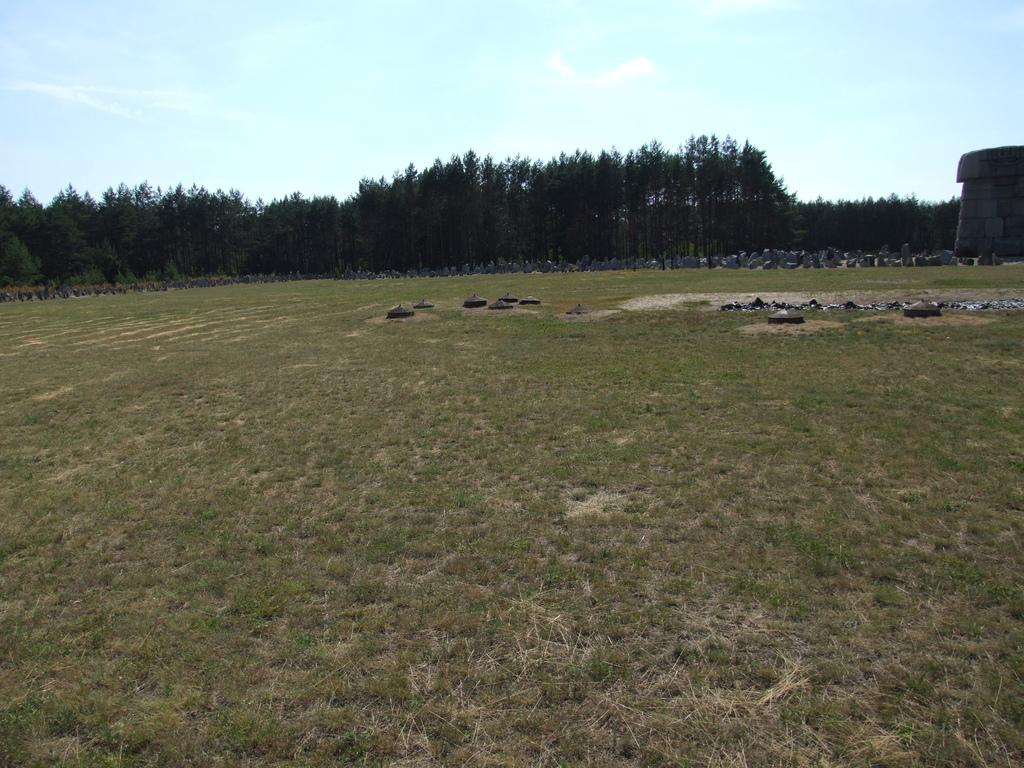What type of vegetation can be seen in the image? There are trees in the image. What structure is located on the right side of the image? There is a building on the right side of the image. What is visible at the top of the image? The sky is visible at the top of the image. What can be seen in the sky in the image? There are clouds in the sky. What type of ground surface is present at the bottom of the image? Grass is present at the bottom of the image. Can you tell me how many wrens are perched on the building in the image? There are no wrens present in the image; it features trees, a building, clouds, and grass. What type of help is being offered by the trees in the image? The trees in the image are not offering any help, as they are inanimate objects. 